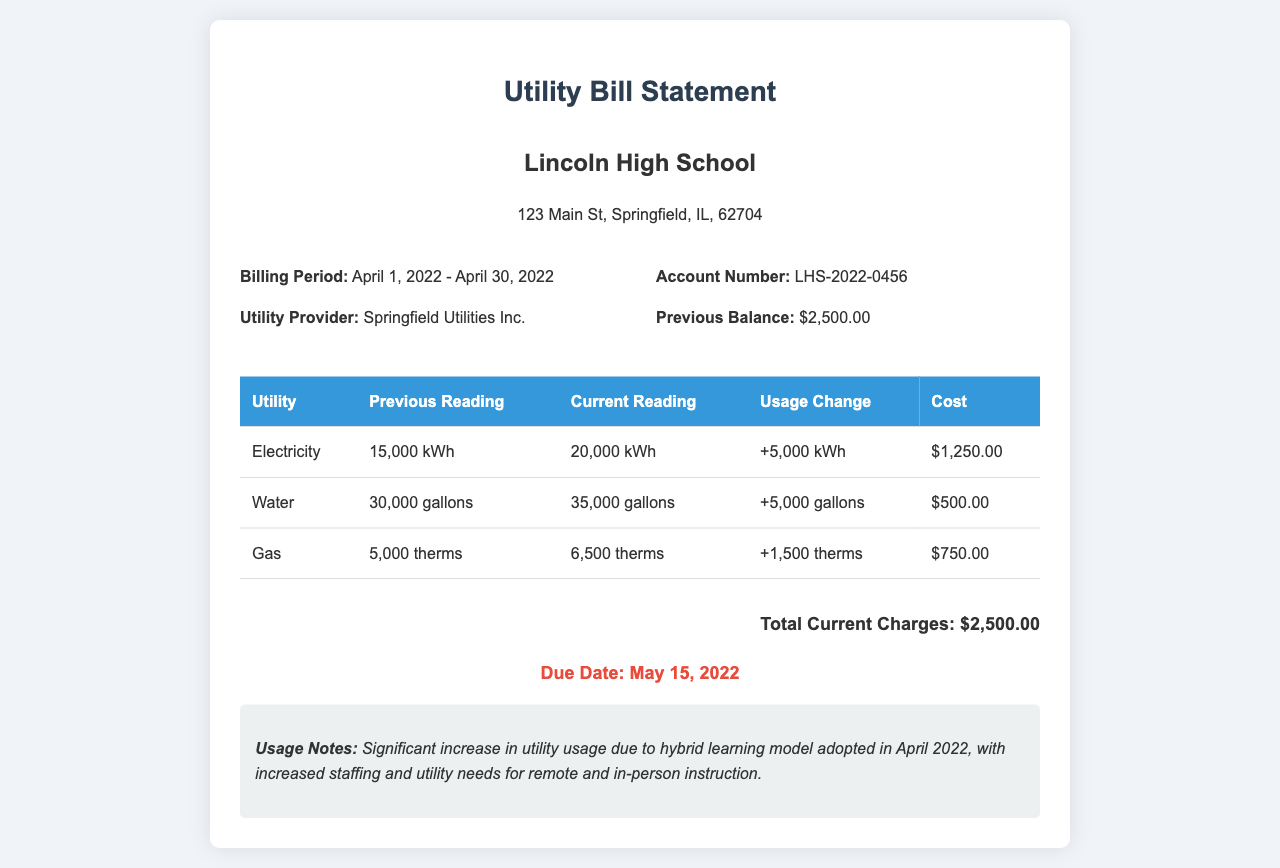What is the billing period? The billing period is stated in the document as the timeframe for which the utilities are measured, which is April 1, 2022 - April 30, 2022.
Answer: April 1, 2022 - April 30, 2022 What is the total current charge? The total current charge is the sum of all utility costs indicated in the document, totaling $2,500.00.
Answer: $2,500.00 What utility shows the highest usage change? The utility with the highest usage change is determined by comparing the "Usage Change" values, which indicates electricity at +5,000 kWh.
Answer: Electricity How much water did the school use in April 2022? The document provides the current water reading figure, which shows that the school used 35,000 gallons.
Answer: 35,000 gallons What is the due date for this bill? The due date is specifically mentioned in the document as the date by which the payment must be made, which is May 15, 2022.
Answer: May 15, 2022 What was the previous balance before this billing statement? The previous balance reflects the amount owed prior to this billing period, which is detailed in the document as $2,500.00.
Answer: $2,500.00 What utility service had the lowest cost this month? The cost associated with each utility determines which is lowest; here, Water at $500.00 indicates it is the lowest cost.
Answer: Water What does the usage notes indicate about the energy usage? The usage notes highlight the changes in utility usage due to different factors, particularly the hybrid learning model adopted during this period.
Answer: Significant increase in utility usage due to hybrid learning model 